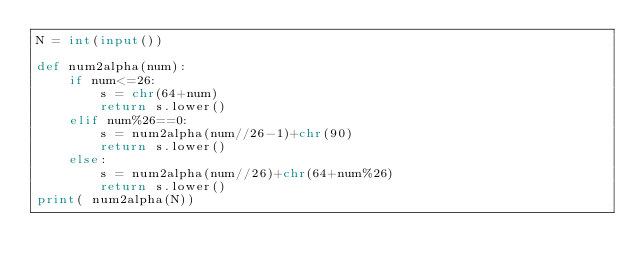<code> <loc_0><loc_0><loc_500><loc_500><_Python_>N = int(input())

def num2alpha(num):
    if num<=26:
        s = chr(64+num)
        return s.lower()
    elif num%26==0:
        s = num2alpha(num//26-1)+chr(90) 
        return s.lower()
    else:
        s = num2alpha(num//26)+chr(64+num%26)
        return s.lower()
print( num2alpha(N))
    </code> 